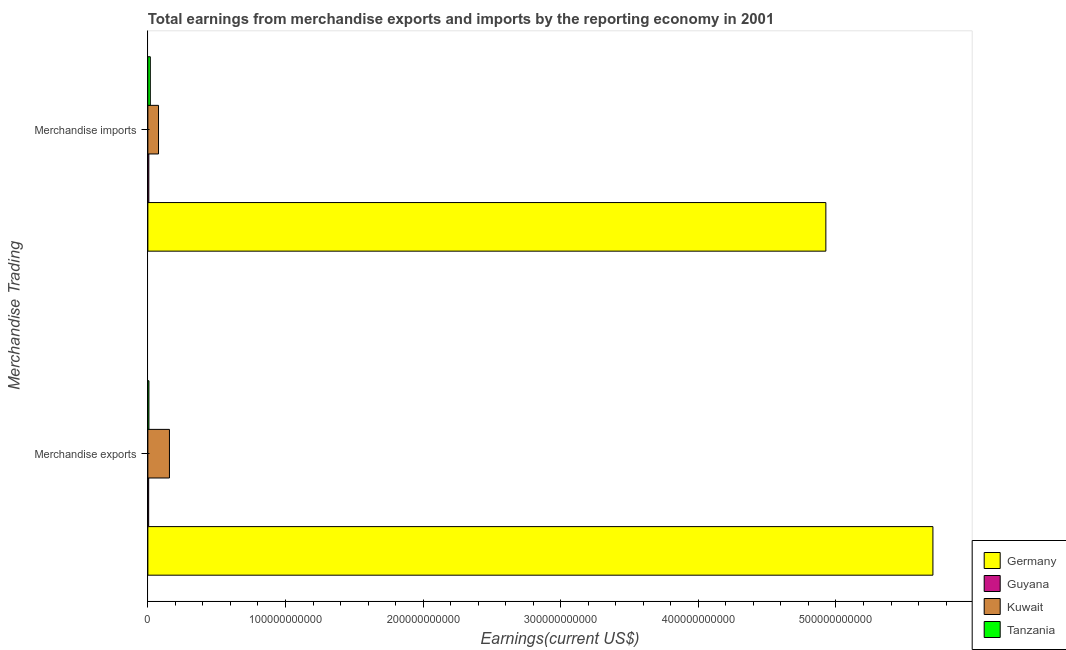How many different coloured bars are there?
Your answer should be compact. 4. Are the number of bars on each tick of the Y-axis equal?
Make the answer very short. Yes. How many bars are there on the 1st tick from the top?
Provide a short and direct response. 4. How many bars are there on the 2nd tick from the bottom?
Your answer should be very brief. 4. What is the earnings from merchandise exports in Tanzania?
Your response must be concise. 7.75e+08. Across all countries, what is the maximum earnings from merchandise imports?
Make the answer very short. 4.93e+11. Across all countries, what is the minimum earnings from merchandise exports?
Offer a terse response. 5.74e+08. In which country was the earnings from merchandise imports minimum?
Make the answer very short. Guyana. What is the total earnings from merchandise imports in the graph?
Offer a very short reply. 5.03e+11. What is the difference between the earnings from merchandise imports in Kuwait and that in Tanzania?
Provide a short and direct response. 5.96e+09. What is the difference between the earnings from merchandise imports in Kuwait and the earnings from merchandise exports in Tanzania?
Your answer should be compact. 6.96e+09. What is the average earnings from merchandise imports per country?
Your response must be concise. 1.26e+11. What is the difference between the earnings from merchandise imports and earnings from merchandise exports in Tanzania?
Give a very brief answer. 1.01e+09. In how many countries, is the earnings from merchandise imports greater than 420000000000 US$?
Offer a terse response. 1. What is the ratio of the earnings from merchandise imports in Kuwait to that in Guyana?
Provide a succinct answer. 11.05. In how many countries, is the earnings from merchandise exports greater than the average earnings from merchandise exports taken over all countries?
Offer a terse response. 1. What does the 3rd bar from the top in Merchandise imports represents?
Make the answer very short. Guyana. What does the 2nd bar from the bottom in Merchandise imports represents?
Offer a very short reply. Guyana. How many bars are there?
Give a very brief answer. 8. How many countries are there in the graph?
Offer a very short reply. 4. What is the difference between two consecutive major ticks on the X-axis?
Make the answer very short. 1.00e+11. Are the values on the major ticks of X-axis written in scientific E-notation?
Your answer should be very brief. No. Does the graph contain grids?
Ensure brevity in your answer.  No. How many legend labels are there?
Your response must be concise. 4. What is the title of the graph?
Keep it short and to the point. Total earnings from merchandise exports and imports by the reporting economy in 2001. What is the label or title of the X-axis?
Ensure brevity in your answer.  Earnings(current US$). What is the label or title of the Y-axis?
Ensure brevity in your answer.  Merchandise Trading. What is the Earnings(current US$) of Germany in Merchandise exports?
Your answer should be compact. 5.70e+11. What is the Earnings(current US$) in Guyana in Merchandise exports?
Your answer should be very brief. 5.74e+08. What is the Earnings(current US$) of Kuwait in Merchandise exports?
Provide a succinct answer. 1.57e+1. What is the Earnings(current US$) in Tanzania in Merchandise exports?
Give a very brief answer. 7.75e+08. What is the Earnings(current US$) in Germany in Merchandise imports?
Give a very brief answer. 4.93e+11. What is the Earnings(current US$) of Guyana in Merchandise imports?
Provide a succinct answer. 7.00e+08. What is the Earnings(current US$) of Kuwait in Merchandise imports?
Your answer should be very brief. 7.74e+09. What is the Earnings(current US$) in Tanzania in Merchandise imports?
Your answer should be compact. 1.78e+09. Across all Merchandise Trading, what is the maximum Earnings(current US$) in Germany?
Provide a short and direct response. 5.70e+11. Across all Merchandise Trading, what is the maximum Earnings(current US$) of Guyana?
Give a very brief answer. 7.00e+08. Across all Merchandise Trading, what is the maximum Earnings(current US$) in Kuwait?
Your answer should be compact. 1.57e+1. Across all Merchandise Trading, what is the maximum Earnings(current US$) in Tanzania?
Give a very brief answer. 1.78e+09. Across all Merchandise Trading, what is the minimum Earnings(current US$) in Germany?
Offer a terse response. 4.93e+11. Across all Merchandise Trading, what is the minimum Earnings(current US$) in Guyana?
Provide a short and direct response. 5.74e+08. Across all Merchandise Trading, what is the minimum Earnings(current US$) in Kuwait?
Your response must be concise. 7.74e+09. Across all Merchandise Trading, what is the minimum Earnings(current US$) in Tanzania?
Ensure brevity in your answer.  7.75e+08. What is the total Earnings(current US$) of Germany in the graph?
Give a very brief answer. 1.06e+12. What is the total Earnings(current US$) of Guyana in the graph?
Keep it short and to the point. 1.27e+09. What is the total Earnings(current US$) in Kuwait in the graph?
Your response must be concise. 2.34e+1. What is the total Earnings(current US$) of Tanzania in the graph?
Offer a very short reply. 2.56e+09. What is the difference between the Earnings(current US$) in Germany in Merchandise exports and that in Merchandise imports?
Your response must be concise. 7.78e+1. What is the difference between the Earnings(current US$) in Guyana in Merchandise exports and that in Merchandise imports?
Your answer should be compact. -1.26e+08. What is the difference between the Earnings(current US$) of Kuwait in Merchandise exports and that in Merchandise imports?
Your answer should be compact. 7.94e+09. What is the difference between the Earnings(current US$) in Tanzania in Merchandise exports and that in Merchandise imports?
Offer a very short reply. -1.01e+09. What is the difference between the Earnings(current US$) in Germany in Merchandise exports and the Earnings(current US$) in Guyana in Merchandise imports?
Your answer should be very brief. 5.70e+11. What is the difference between the Earnings(current US$) of Germany in Merchandise exports and the Earnings(current US$) of Kuwait in Merchandise imports?
Give a very brief answer. 5.63e+11. What is the difference between the Earnings(current US$) of Germany in Merchandise exports and the Earnings(current US$) of Tanzania in Merchandise imports?
Offer a very short reply. 5.69e+11. What is the difference between the Earnings(current US$) of Guyana in Merchandise exports and the Earnings(current US$) of Kuwait in Merchandise imports?
Your answer should be very brief. -7.17e+09. What is the difference between the Earnings(current US$) in Guyana in Merchandise exports and the Earnings(current US$) in Tanzania in Merchandise imports?
Offer a terse response. -1.21e+09. What is the difference between the Earnings(current US$) of Kuwait in Merchandise exports and the Earnings(current US$) of Tanzania in Merchandise imports?
Your answer should be compact. 1.39e+1. What is the average Earnings(current US$) in Germany per Merchandise Trading?
Keep it short and to the point. 5.32e+11. What is the average Earnings(current US$) in Guyana per Merchandise Trading?
Your response must be concise. 6.37e+08. What is the average Earnings(current US$) in Kuwait per Merchandise Trading?
Make the answer very short. 1.17e+1. What is the average Earnings(current US$) of Tanzania per Merchandise Trading?
Offer a terse response. 1.28e+09. What is the difference between the Earnings(current US$) in Germany and Earnings(current US$) in Guyana in Merchandise exports?
Give a very brief answer. 5.70e+11. What is the difference between the Earnings(current US$) in Germany and Earnings(current US$) in Kuwait in Merchandise exports?
Provide a succinct answer. 5.55e+11. What is the difference between the Earnings(current US$) in Germany and Earnings(current US$) in Tanzania in Merchandise exports?
Make the answer very short. 5.70e+11. What is the difference between the Earnings(current US$) in Guyana and Earnings(current US$) in Kuwait in Merchandise exports?
Offer a very short reply. -1.51e+1. What is the difference between the Earnings(current US$) in Guyana and Earnings(current US$) in Tanzania in Merchandise exports?
Give a very brief answer. -2.01e+08. What is the difference between the Earnings(current US$) in Kuwait and Earnings(current US$) in Tanzania in Merchandise exports?
Provide a succinct answer. 1.49e+1. What is the difference between the Earnings(current US$) of Germany and Earnings(current US$) of Guyana in Merchandise imports?
Offer a terse response. 4.92e+11. What is the difference between the Earnings(current US$) in Germany and Earnings(current US$) in Kuwait in Merchandise imports?
Your answer should be compact. 4.85e+11. What is the difference between the Earnings(current US$) in Germany and Earnings(current US$) in Tanzania in Merchandise imports?
Provide a short and direct response. 4.91e+11. What is the difference between the Earnings(current US$) of Guyana and Earnings(current US$) of Kuwait in Merchandise imports?
Provide a succinct answer. -7.04e+09. What is the difference between the Earnings(current US$) of Guyana and Earnings(current US$) of Tanzania in Merchandise imports?
Ensure brevity in your answer.  -1.08e+09. What is the difference between the Earnings(current US$) of Kuwait and Earnings(current US$) of Tanzania in Merchandise imports?
Provide a short and direct response. 5.96e+09. What is the ratio of the Earnings(current US$) of Germany in Merchandise exports to that in Merchandise imports?
Provide a succinct answer. 1.16. What is the ratio of the Earnings(current US$) in Guyana in Merchandise exports to that in Merchandise imports?
Your answer should be very brief. 0.82. What is the ratio of the Earnings(current US$) in Kuwait in Merchandise exports to that in Merchandise imports?
Make the answer very short. 2.03. What is the ratio of the Earnings(current US$) of Tanzania in Merchandise exports to that in Merchandise imports?
Provide a short and direct response. 0.44. What is the difference between the highest and the second highest Earnings(current US$) of Germany?
Ensure brevity in your answer.  7.78e+1. What is the difference between the highest and the second highest Earnings(current US$) in Guyana?
Offer a terse response. 1.26e+08. What is the difference between the highest and the second highest Earnings(current US$) of Kuwait?
Ensure brevity in your answer.  7.94e+09. What is the difference between the highest and the second highest Earnings(current US$) of Tanzania?
Your response must be concise. 1.01e+09. What is the difference between the highest and the lowest Earnings(current US$) in Germany?
Your response must be concise. 7.78e+1. What is the difference between the highest and the lowest Earnings(current US$) in Guyana?
Your answer should be compact. 1.26e+08. What is the difference between the highest and the lowest Earnings(current US$) of Kuwait?
Give a very brief answer. 7.94e+09. What is the difference between the highest and the lowest Earnings(current US$) of Tanzania?
Offer a very short reply. 1.01e+09. 